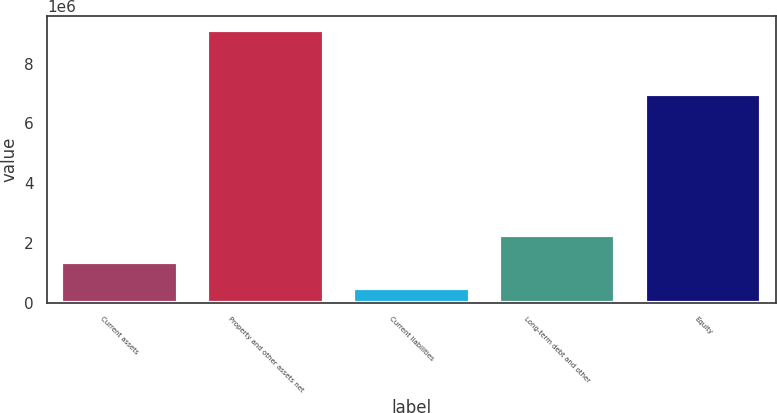<chart> <loc_0><loc_0><loc_500><loc_500><bar_chart><fcel>Current assets<fcel>Property and other assets net<fcel>Current liabilities<fcel>Long-term debt and other<fcel>Equity<nl><fcel>1.34726e+06<fcel>9.12887e+06<fcel>482633<fcel>2.26816e+06<fcel>6.97096e+06<nl></chart> 